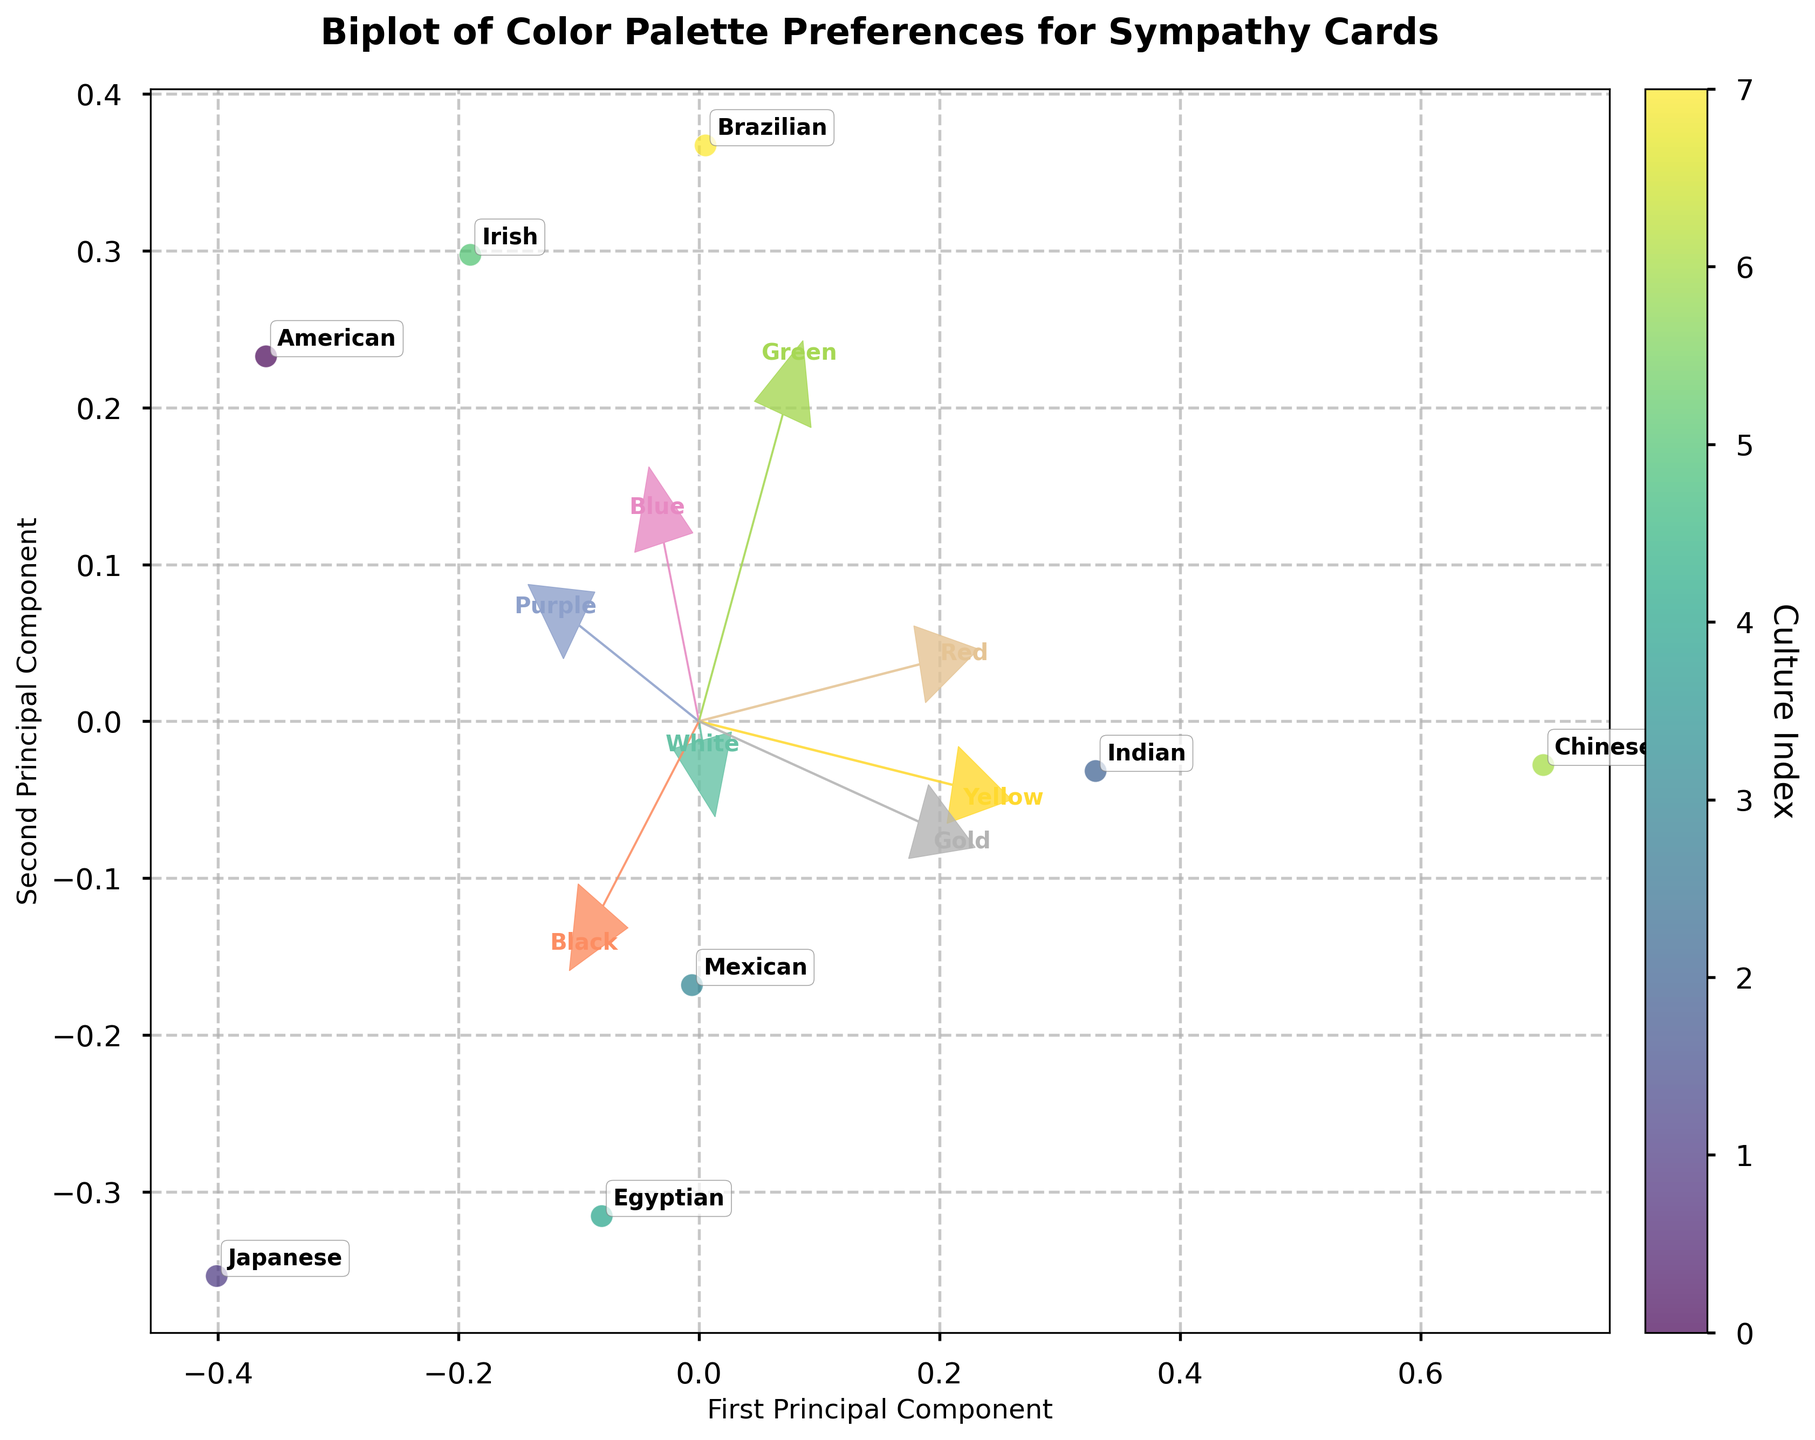What is the title of the figure? The title of the figure is clearly displayed at the top of the plot and summarizes its content.
Answer: Biplot of Color Palette Preferences for Sympathy Cards How many cultures are represented in the biplot? By counting the distinct labels annotated on the plot, we can determine the number of different cultures included.
Answer: 8 Which culture is located closest to the origin (0,0) in the biplot? By observing the position of the data points relative to the origin, we can identify the culture closest to the (0,0) coordinate.
Answer: Irish What does the color bar on the right side of the biplot represent? The color bar represents the culture index, as indicated by its label. Each color corresponds to a different cultural data point.
Answer: Culture Index Which color preference has the longest loading vector in the biplot? The loading vectors are depicted as arrows. The length of these arrows indicates the strength of each color preference's contribution to the principal components. By comparing the lengths visually, the longest arrow can be determined.
Answer: Chinese How do American and Chinese color palette preferences differ in the biplot? By locating the 'American' and 'Chinese' data points on the biplot and comparing their positions, we can infer differences in their color preferences.
Answer: They are quite distinct, with American preferences leaning strongly towards 'White' and 'Chinese' towards 'Red' and 'Gold' What is the interpretation of a culture positioned far from the origin in the biplot? This indicates that the culture has distinct color palette preferences compared to others. Cultures far from the origin have more extreme values in certain color preferences.
Answer: Distinct color preferences Are there any cultures with similar color palette preferences shown close together on the biplot? By identifying clusters or groups of cultures close to each other on the plot, we can infer similarity in their color preferences.
Answer: Yes, Mexican and Brazilian are close together Which color preference is most negatively correlated with the first principal component? The loading vectors can show which color vectors point in the negative direction of the first principal component axis. The longest arrow in this negative direction represents the most negative correlation.
Answer: Green Based on the biplot, which cultures have a high preference for the color 'White'? Cultures with high preferences for 'White' will be located in the direction of the 'White' loading vector.
Answer: American, Japanese, and Chinese 